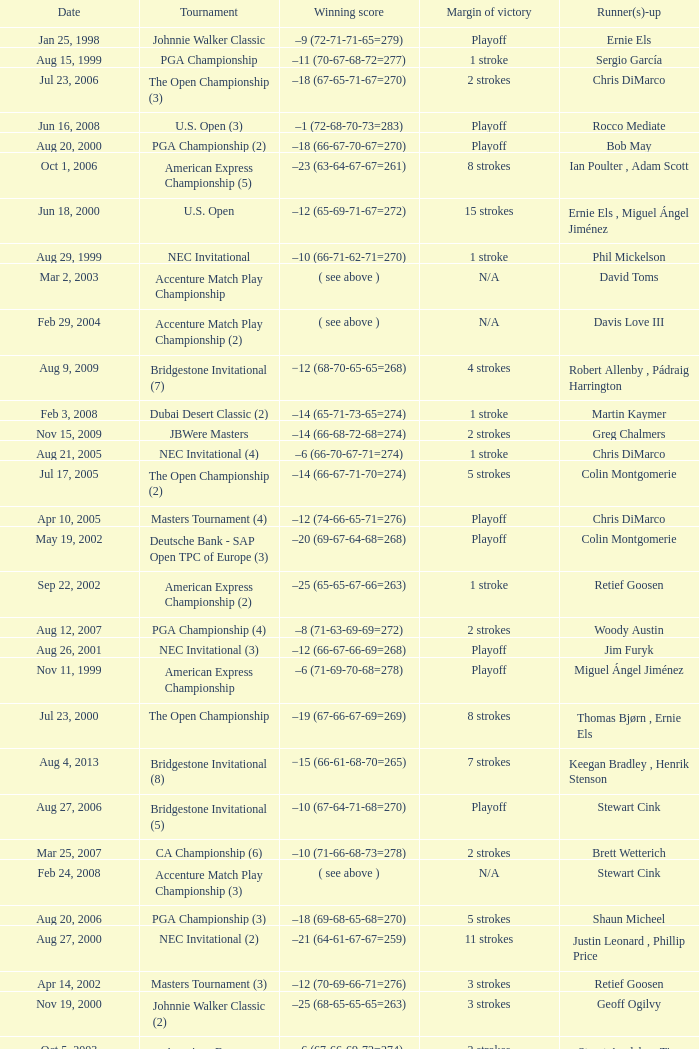Who is Runner(s)-up that has a Date of may 24, 1999? Retief Goosen. 